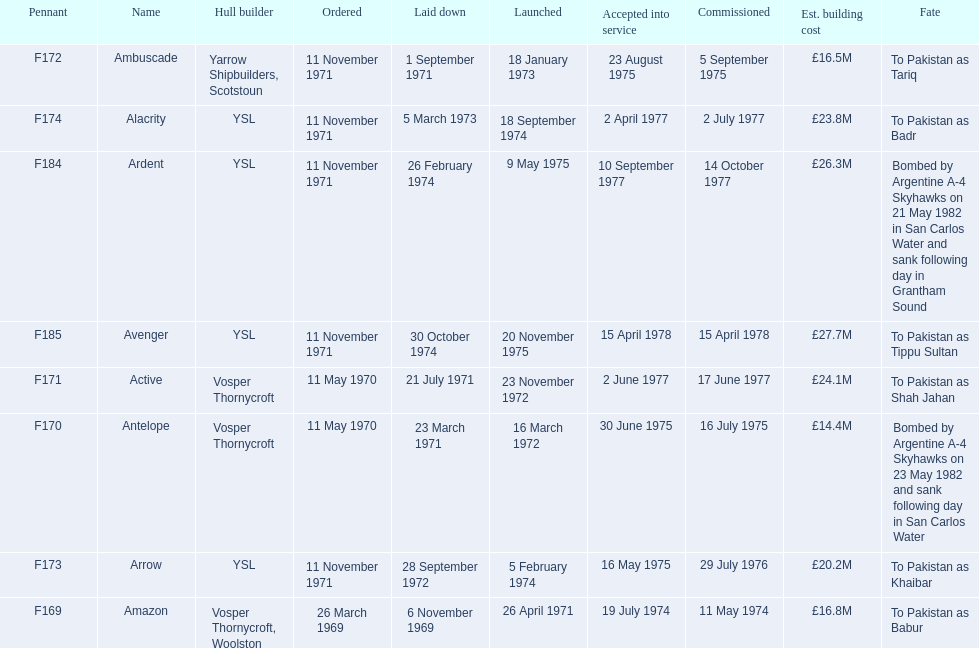The arrow was ordered on november 11, 1971. what was the previous ship? Ambuscade. 